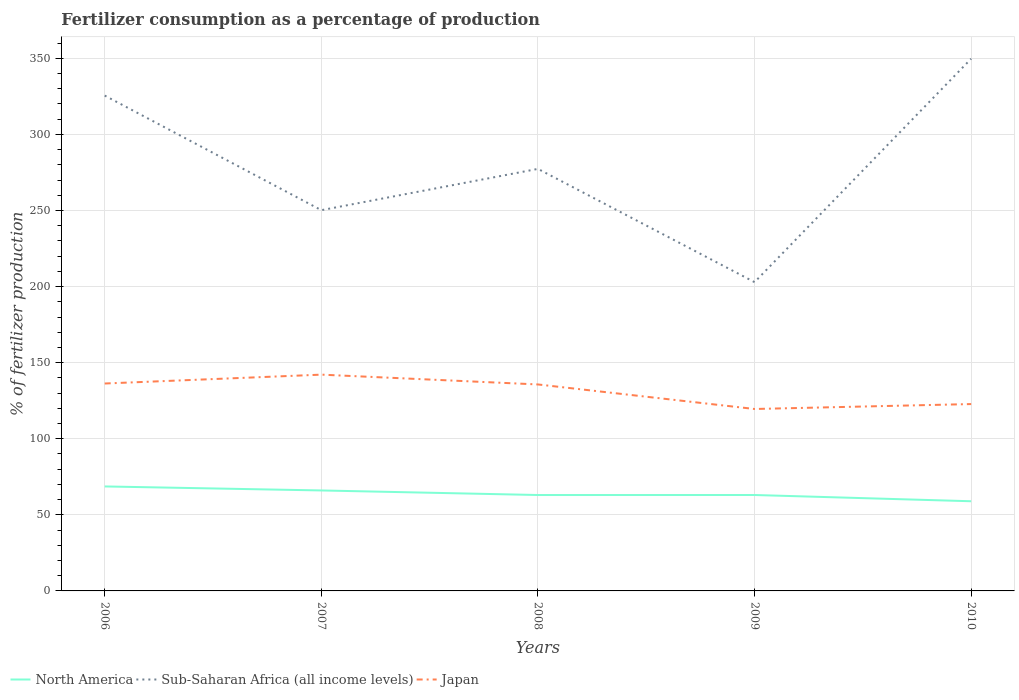Does the line corresponding to North America intersect with the line corresponding to Japan?
Make the answer very short. No. Across all years, what is the maximum percentage of fertilizers consumed in North America?
Provide a succinct answer. 58.93. In which year was the percentage of fertilizers consumed in Japan maximum?
Your response must be concise. 2009. What is the total percentage of fertilizers consumed in North America in the graph?
Ensure brevity in your answer.  5.63. What is the difference between the highest and the second highest percentage of fertilizers consumed in Japan?
Your answer should be compact. 22.58. What is the difference between the highest and the lowest percentage of fertilizers consumed in North America?
Provide a succinct answer. 2. Is the percentage of fertilizers consumed in Sub-Saharan Africa (all income levels) strictly greater than the percentage of fertilizers consumed in North America over the years?
Offer a very short reply. No. How many years are there in the graph?
Your answer should be compact. 5. What is the difference between two consecutive major ticks on the Y-axis?
Offer a terse response. 50. Are the values on the major ticks of Y-axis written in scientific E-notation?
Provide a succinct answer. No. Does the graph contain any zero values?
Provide a succinct answer. No. Does the graph contain grids?
Offer a very short reply. Yes. Where does the legend appear in the graph?
Your answer should be compact. Bottom left. What is the title of the graph?
Ensure brevity in your answer.  Fertilizer consumption as a percentage of production. Does "Aruba" appear as one of the legend labels in the graph?
Ensure brevity in your answer.  No. What is the label or title of the Y-axis?
Offer a very short reply. % of fertilizer production. What is the % of fertilizer production of North America in 2006?
Provide a succinct answer. 68.66. What is the % of fertilizer production in Sub-Saharan Africa (all income levels) in 2006?
Make the answer very short. 325.51. What is the % of fertilizer production in Japan in 2006?
Provide a succinct answer. 136.3. What is the % of fertilizer production in North America in 2007?
Keep it short and to the point. 66.02. What is the % of fertilizer production in Sub-Saharan Africa (all income levels) in 2007?
Your answer should be compact. 250.2. What is the % of fertilizer production in Japan in 2007?
Keep it short and to the point. 142.13. What is the % of fertilizer production of North America in 2008?
Offer a very short reply. 63.03. What is the % of fertilizer production of Sub-Saharan Africa (all income levels) in 2008?
Keep it short and to the point. 277.34. What is the % of fertilizer production in Japan in 2008?
Ensure brevity in your answer.  135.68. What is the % of fertilizer production of North America in 2009?
Make the answer very short. 63.04. What is the % of fertilizer production in Sub-Saharan Africa (all income levels) in 2009?
Give a very brief answer. 202.92. What is the % of fertilizer production of Japan in 2009?
Provide a succinct answer. 119.55. What is the % of fertilizer production in North America in 2010?
Make the answer very short. 58.93. What is the % of fertilizer production in Sub-Saharan Africa (all income levels) in 2010?
Offer a very short reply. 349.74. What is the % of fertilizer production of Japan in 2010?
Provide a short and direct response. 122.8. Across all years, what is the maximum % of fertilizer production in North America?
Your response must be concise. 68.66. Across all years, what is the maximum % of fertilizer production in Sub-Saharan Africa (all income levels)?
Provide a short and direct response. 349.74. Across all years, what is the maximum % of fertilizer production in Japan?
Your answer should be compact. 142.13. Across all years, what is the minimum % of fertilizer production in North America?
Keep it short and to the point. 58.93. Across all years, what is the minimum % of fertilizer production of Sub-Saharan Africa (all income levels)?
Your answer should be compact. 202.92. Across all years, what is the minimum % of fertilizer production in Japan?
Your answer should be very brief. 119.55. What is the total % of fertilizer production in North America in the graph?
Give a very brief answer. 319.68. What is the total % of fertilizer production in Sub-Saharan Africa (all income levels) in the graph?
Your answer should be compact. 1405.71. What is the total % of fertilizer production in Japan in the graph?
Offer a very short reply. 656.45. What is the difference between the % of fertilizer production of North America in 2006 and that in 2007?
Make the answer very short. 2.64. What is the difference between the % of fertilizer production in Sub-Saharan Africa (all income levels) in 2006 and that in 2007?
Offer a very short reply. 75.31. What is the difference between the % of fertilizer production of Japan in 2006 and that in 2007?
Your answer should be compact. -5.83. What is the difference between the % of fertilizer production of North America in 2006 and that in 2008?
Provide a short and direct response. 5.64. What is the difference between the % of fertilizer production of Sub-Saharan Africa (all income levels) in 2006 and that in 2008?
Your response must be concise. 48.17. What is the difference between the % of fertilizer production of Japan in 2006 and that in 2008?
Give a very brief answer. 0.62. What is the difference between the % of fertilizer production in North America in 2006 and that in 2009?
Make the answer very short. 5.63. What is the difference between the % of fertilizer production in Sub-Saharan Africa (all income levels) in 2006 and that in 2009?
Offer a terse response. 122.59. What is the difference between the % of fertilizer production in Japan in 2006 and that in 2009?
Your answer should be compact. 16.74. What is the difference between the % of fertilizer production of North America in 2006 and that in 2010?
Provide a short and direct response. 9.74. What is the difference between the % of fertilizer production of Sub-Saharan Africa (all income levels) in 2006 and that in 2010?
Your answer should be very brief. -24.23. What is the difference between the % of fertilizer production of Japan in 2006 and that in 2010?
Provide a short and direct response. 13.5. What is the difference between the % of fertilizer production in North America in 2007 and that in 2008?
Your answer should be compact. 3. What is the difference between the % of fertilizer production of Sub-Saharan Africa (all income levels) in 2007 and that in 2008?
Make the answer very short. -27.14. What is the difference between the % of fertilizer production of Japan in 2007 and that in 2008?
Your answer should be compact. 6.45. What is the difference between the % of fertilizer production of North America in 2007 and that in 2009?
Offer a very short reply. 2.98. What is the difference between the % of fertilizer production in Sub-Saharan Africa (all income levels) in 2007 and that in 2009?
Your answer should be compact. 47.29. What is the difference between the % of fertilizer production of Japan in 2007 and that in 2009?
Offer a very short reply. 22.58. What is the difference between the % of fertilizer production in North America in 2007 and that in 2010?
Your response must be concise. 7.09. What is the difference between the % of fertilizer production in Sub-Saharan Africa (all income levels) in 2007 and that in 2010?
Offer a very short reply. -99.54. What is the difference between the % of fertilizer production in Japan in 2007 and that in 2010?
Provide a succinct answer. 19.33. What is the difference between the % of fertilizer production in North America in 2008 and that in 2009?
Offer a very short reply. -0.01. What is the difference between the % of fertilizer production of Sub-Saharan Africa (all income levels) in 2008 and that in 2009?
Provide a succinct answer. 74.42. What is the difference between the % of fertilizer production of Japan in 2008 and that in 2009?
Give a very brief answer. 16.13. What is the difference between the % of fertilizer production of North America in 2008 and that in 2010?
Keep it short and to the point. 4.1. What is the difference between the % of fertilizer production of Sub-Saharan Africa (all income levels) in 2008 and that in 2010?
Offer a very short reply. -72.4. What is the difference between the % of fertilizer production of Japan in 2008 and that in 2010?
Make the answer very short. 12.88. What is the difference between the % of fertilizer production of North America in 2009 and that in 2010?
Offer a terse response. 4.11. What is the difference between the % of fertilizer production of Sub-Saharan Africa (all income levels) in 2009 and that in 2010?
Offer a very short reply. -146.83. What is the difference between the % of fertilizer production in Japan in 2009 and that in 2010?
Make the answer very short. -3.24. What is the difference between the % of fertilizer production of North America in 2006 and the % of fertilizer production of Sub-Saharan Africa (all income levels) in 2007?
Offer a very short reply. -181.54. What is the difference between the % of fertilizer production of North America in 2006 and the % of fertilizer production of Japan in 2007?
Make the answer very short. -73.46. What is the difference between the % of fertilizer production of Sub-Saharan Africa (all income levels) in 2006 and the % of fertilizer production of Japan in 2007?
Your answer should be very brief. 183.38. What is the difference between the % of fertilizer production in North America in 2006 and the % of fertilizer production in Sub-Saharan Africa (all income levels) in 2008?
Provide a succinct answer. -208.67. What is the difference between the % of fertilizer production in North America in 2006 and the % of fertilizer production in Japan in 2008?
Provide a short and direct response. -67.02. What is the difference between the % of fertilizer production in Sub-Saharan Africa (all income levels) in 2006 and the % of fertilizer production in Japan in 2008?
Your response must be concise. 189.83. What is the difference between the % of fertilizer production in North America in 2006 and the % of fertilizer production in Sub-Saharan Africa (all income levels) in 2009?
Provide a short and direct response. -134.25. What is the difference between the % of fertilizer production in North America in 2006 and the % of fertilizer production in Japan in 2009?
Make the answer very short. -50.89. What is the difference between the % of fertilizer production in Sub-Saharan Africa (all income levels) in 2006 and the % of fertilizer production in Japan in 2009?
Provide a short and direct response. 205.96. What is the difference between the % of fertilizer production in North America in 2006 and the % of fertilizer production in Sub-Saharan Africa (all income levels) in 2010?
Provide a short and direct response. -281.08. What is the difference between the % of fertilizer production in North America in 2006 and the % of fertilizer production in Japan in 2010?
Keep it short and to the point. -54.13. What is the difference between the % of fertilizer production in Sub-Saharan Africa (all income levels) in 2006 and the % of fertilizer production in Japan in 2010?
Make the answer very short. 202.71. What is the difference between the % of fertilizer production of North America in 2007 and the % of fertilizer production of Sub-Saharan Africa (all income levels) in 2008?
Make the answer very short. -211.32. What is the difference between the % of fertilizer production of North America in 2007 and the % of fertilizer production of Japan in 2008?
Your answer should be compact. -69.66. What is the difference between the % of fertilizer production of Sub-Saharan Africa (all income levels) in 2007 and the % of fertilizer production of Japan in 2008?
Offer a very short reply. 114.52. What is the difference between the % of fertilizer production in North America in 2007 and the % of fertilizer production in Sub-Saharan Africa (all income levels) in 2009?
Provide a short and direct response. -136.89. What is the difference between the % of fertilizer production of North America in 2007 and the % of fertilizer production of Japan in 2009?
Ensure brevity in your answer.  -53.53. What is the difference between the % of fertilizer production in Sub-Saharan Africa (all income levels) in 2007 and the % of fertilizer production in Japan in 2009?
Ensure brevity in your answer.  130.65. What is the difference between the % of fertilizer production in North America in 2007 and the % of fertilizer production in Sub-Saharan Africa (all income levels) in 2010?
Your response must be concise. -283.72. What is the difference between the % of fertilizer production in North America in 2007 and the % of fertilizer production in Japan in 2010?
Your response must be concise. -56.77. What is the difference between the % of fertilizer production in Sub-Saharan Africa (all income levels) in 2007 and the % of fertilizer production in Japan in 2010?
Your answer should be compact. 127.41. What is the difference between the % of fertilizer production of North America in 2008 and the % of fertilizer production of Sub-Saharan Africa (all income levels) in 2009?
Keep it short and to the point. -139.89. What is the difference between the % of fertilizer production in North America in 2008 and the % of fertilizer production in Japan in 2009?
Provide a short and direct response. -56.53. What is the difference between the % of fertilizer production of Sub-Saharan Africa (all income levels) in 2008 and the % of fertilizer production of Japan in 2009?
Your response must be concise. 157.79. What is the difference between the % of fertilizer production of North America in 2008 and the % of fertilizer production of Sub-Saharan Africa (all income levels) in 2010?
Make the answer very short. -286.72. What is the difference between the % of fertilizer production of North America in 2008 and the % of fertilizer production of Japan in 2010?
Your answer should be compact. -59.77. What is the difference between the % of fertilizer production of Sub-Saharan Africa (all income levels) in 2008 and the % of fertilizer production of Japan in 2010?
Provide a succinct answer. 154.54. What is the difference between the % of fertilizer production in North America in 2009 and the % of fertilizer production in Sub-Saharan Africa (all income levels) in 2010?
Your answer should be compact. -286.71. What is the difference between the % of fertilizer production of North America in 2009 and the % of fertilizer production of Japan in 2010?
Your answer should be compact. -59.76. What is the difference between the % of fertilizer production of Sub-Saharan Africa (all income levels) in 2009 and the % of fertilizer production of Japan in 2010?
Offer a very short reply. 80.12. What is the average % of fertilizer production in North America per year?
Provide a short and direct response. 63.94. What is the average % of fertilizer production of Sub-Saharan Africa (all income levels) per year?
Provide a succinct answer. 281.14. What is the average % of fertilizer production in Japan per year?
Keep it short and to the point. 131.29. In the year 2006, what is the difference between the % of fertilizer production in North America and % of fertilizer production in Sub-Saharan Africa (all income levels)?
Your response must be concise. -256.84. In the year 2006, what is the difference between the % of fertilizer production of North America and % of fertilizer production of Japan?
Offer a terse response. -67.63. In the year 2006, what is the difference between the % of fertilizer production of Sub-Saharan Africa (all income levels) and % of fertilizer production of Japan?
Keep it short and to the point. 189.21. In the year 2007, what is the difference between the % of fertilizer production in North America and % of fertilizer production in Sub-Saharan Africa (all income levels)?
Keep it short and to the point. -184.18. In the year 2007, what is the difference between the % of fertilizer production in North America and % of fertilizer production in Japan?
Provide a short and direct response. -76.11. In the year 2007, what is the difference between the % of fertilizer production of Sub-Saharan Africa (all income levels) and % of fertilizer production of Japan?
Your response must be concise. 108.08. In the year 2008, what is the difference between the % of fertilizer production in North America and % of fertilizer production in Sub-Saharan Africa (all income levels)?
Make the answer very short. -214.31. In the year 2008, what is the difference between the % of fertilizer production of North America and % of fertilizer production of Japan?
Provide a succinct answer. -72.65. In the year 2008, what is the difference between the % of fertilizer production of Sub-Saharan Africa (all income levels) and % of fertilizer production of Japan?
Provide a short and direct response. 141.66. In the year 2009, what is the difference between the % of fertilizer production of North America and % of fertilizer production of Sub-Saharan Africa (all income levels)?
Your answer should be compact. -139.88. In the year 2009, what is the difference between the % of fertilizer production in North America and % of fertilizer production in Japan?
Your answer should be very brief. -56.52. In the year 2009, what is the difference between the % of fertilizer production in Sub-Saharan Africa (all income levels) and % of fertilizer production in Japan?
Provide a succinct answer. 83.36. In the year 2010, what is the difference between the % of fertilizer production of North America and % of fertilizer production of Sub-Saharan Africa (all income levels)?
Keep it short and to the point. -290.81. In the year 2010, what is the difference between the % of fertilizer production of North America and % of fertilizer production of Japan?
Make the answer very short. -63.87. In the year 2010, what is the difference between the % of fertilizer production in Sub-Saharan Africa (all income levels) and % of fertilizer production in Japan?
Your answer should be very brief. 226.95. What is the ratio of the % of fertilizer production in North America in 2006 to that in 2007?
Keep it short and to the point. 1.04. What is the ratio of the % of fertilizer production of Sub-Saharan Africa (all income levels) in 2006 to that in 2007?
Your response must be concise. 1.3. What is the ratio of the % of fertilizer production in Japan in 2006 to that in 2007?
Provide a succinct answer. 0.96. What is the ratio of the % of fertilizer production of North America in 2006 to that in 2008?
Your answer should be very brief. 1.09. What is the ratio of the % of fertilizer production of Sub-Saharan Africa (all income levels) in 2006 to that in 2008?
Ensure brevity in your answer.  1.17. What is the ratio of the % of fertilizer production of North America in 2006 to that in 2009?
Offer a very short reply. 1.09. What is the ratio of the % of fertilizer production of Sub-Saharan Africa (all income levels) in 2006 to that in 2009?
Your answer should be very brief. 1.6. What is the ratio of the % of fertilizer production in Japan in 2006 to that in 2009?
Give a very brief answer. 1.14. What is the ratio of the % of fertilizer production of North America in 2006 to that in 2010?
Your answer should be compact. 1.17. What is the ratio of the % of fertilizer production of Sub-Saharan Africa (all income levels) in 2006 to that in 2010?
Offer a very short reply. 0.93. What is the ratio of the % of fertilizer production in Japan in 2006 to that in 2010?
Make the answer very short. 1.11. What is the ratio of the % of fertilizer production in North America in 2007 to that in 2008?
Offer a terse response. 1.05. What is the ratio of the % of fertilizer production in Sub-Saharan Africa (all income levels) in 2007 to that in 2008?
Provide a short and direct response. 0.9. What is the ratio of the % of fertilizer production of Japan in 2007 to that in 2008?
Your answer should be compact. 1.05. What is the ratio of the % of fertilizer production in North America in 2007 to that in 2009?
Keep it short and to the point. 1.05. What is the ratio of the % of fertilizer production in Sub-Saharan Africa (all income levels) in 2007 to that in 2009?
Your response must be concise. 1.23. What is the ratio of the % of fertilizer production of Japan in 2007 to that in 2009?
Give a very brief answer. 1.19. What is the ratio of the % of fertilizer production of North America in 2007 to that in 2010?
Ensure brevity in your answer.  1.12. What is the ratio of the % of fertilizer production of Sub-Saharan Africa (all income levels) in 2007 to that in 2010?
Keep it short and to the point. 0.72. What is the ratio of the % of fertilizer production in Japan in 2007 to that in 2010?
Give a very brief answer. 1.16. What is the ratio of the % of fertilizer production in Sub-Saharan Africa (all income levels) in 2008 to that in 2009?
Offer a very short reply. 1.37. What is the ratio of the % of fertilizer production in Japan in 2008 to that in 2009?
Provide a succinct answer. 1.13. What is the ratio of the % of fertilizer production in North America in 2008 to that in 2010?
Give a very brief answer. 1.07. What is the ratio of the % of fertilizer production in Sub-Saharan Africa (all income levels) in 2008 to that in 2010?
Your response must be concise. 0.79. What is the ratio of the % of fertilizer production in Japan in 2008 to that in 2010?
Provide a short and direct response. 1.1. What is the ratio of the % of fertilizer production in North America in 2009 to that in 2010?
Keep it short and to the point. 1.07. What is the ratio of the % of fertilizer production in Sub-Saharan Africa (all income levels) in 2009 to that in 2010?
Offer a very short reply. 0.58. What is the ratio of the % of fertilizer production in Japan in 2009 to that in 2010?
Your answer should be compact. 0.97. What is the difference between the highest and the second highest % of fertilizer production in North America?
Your answer should be compact. 2.64. What is the difference between the highest and the second highest % of fertilizer production of Sub-Saharan Africa (all income levels)?
Provide a succinct answer. 24.23. What is the difference between the highest and the second highest % of fertilizer production in Japan?
Make the answer very short. 5.83. What is the difference between the highest and the lowest % of fertilizer production of North America?
Offer a terse response. 9.74. What is the difference between the highest and the lowest % of fertilizer production of Sub-Saharan Africa (all income levels)?
Your answer should be very brief. 146.83. What is the difference between the highest and the lowest % of fertilizer production in Japan?
Your response must be concise. 22.58. 